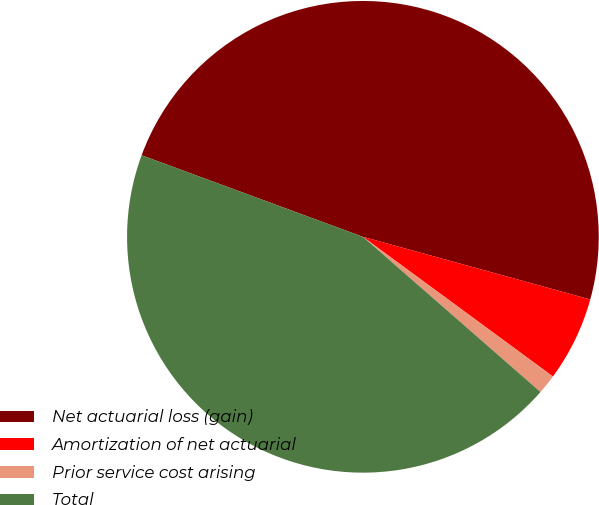Convert chart. <chart><loc_0><loc_0><loc_500><loc_500><pie_chart><fcel>Net actuarial loss (gain)<fcel>Amortization of net actuarial<fcel>Prior service cost arising<fcel>Total<nl><fcel>48.66%<fcel>5.81%<fcel>1.34%<fcel>44.19%<nl></chart> 